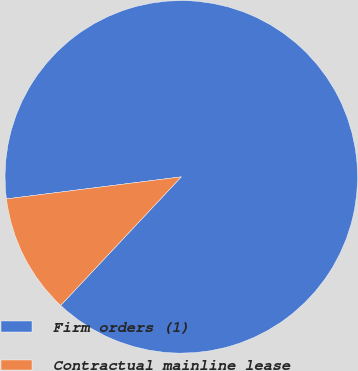Convert chart. <chart><loc_0><loc_0><loc_500><loc_500><pie_chart><fcel>Firm orders (1)<fcel>Contractual mainline lease<nl><fcel>88.99%<fcel>11.01%<nl></chart> 